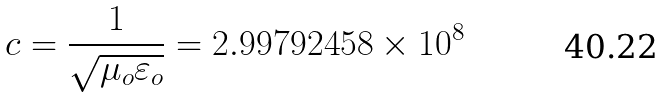<formula> <loc_0><loc_0><loc_500><loc_500>c = { \frac { 1 } { \sqrt { \mu _ { o } \varepsilon _ { o } } } } = 2 . 9 9 7 9 2 4 5 8 \times 1 0 ^ { 8 }</formula> 